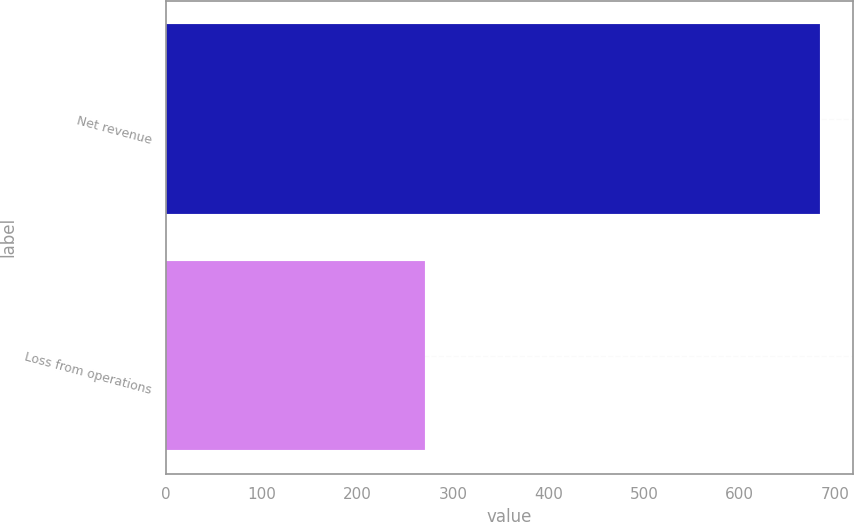<chart> <loc_0><loc_0><loc_500><loc_500><bar_chart><fcel>Net revenue<fcel>Loss from operations<nl><fcel>684<fcel>271<nl></chart> 